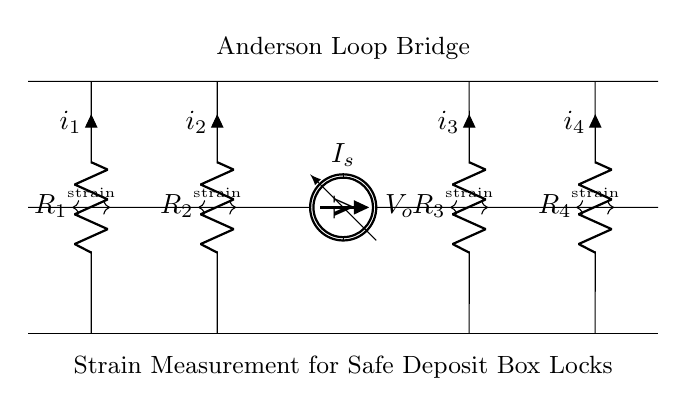What is the type of this circuit? This circuit is an Anderson Loop Bridge, specifically labeled in the diagram. The label indicates its specific design and function for measuring strain.
Answer: Anderson Loop Bridge What components are used in this circuit? The circuit consists of four resistors labeled R1, R2, R3, and R4, a current source labeled Is, and a voltmeter labeled Vo. These components are the primary elements shown in the diagram.
Answer: R1, R2, R3, R4, Is, Vo What does the voltmeter measure? The voltmeter, labeled V0, measures the potential difference across the bridge circuit caused by the strain applied to the resistors. This is a key function in strain measurement applications.
Answer: V0 How many resistors are in this circuit? The diagram shows four resistors (R1, R2, R3, R4) connected in the loop. From direct observation of the circuit, we can count the resistors depicted.
Answer: Four What is the purpose of the strain gauges in this circuit? The strain gauges, represented by resistors R1, R2, R3, and R4, serve to detect changes in resistance as they undergo strain, providing a way to measure physical stress or deformation on the secure deposit box locks.
Answer: Detect strain What does the current source provide? The current source labeled Is provides a steady flow of current throughout the circuit, necessary for the operation of the strain gauges and for obtaining voltage readings from the voltmeter.
Answer: Steady current How does the circuit connect to the safe deposit box locks? The circuit's strain gauges are designed to be positioned on or near the locking mechanism of the safe deposit box, allowing them to measure stress or deformation that occurs when the lock is engaged or disengaged.
Answer: Measures lock strain 